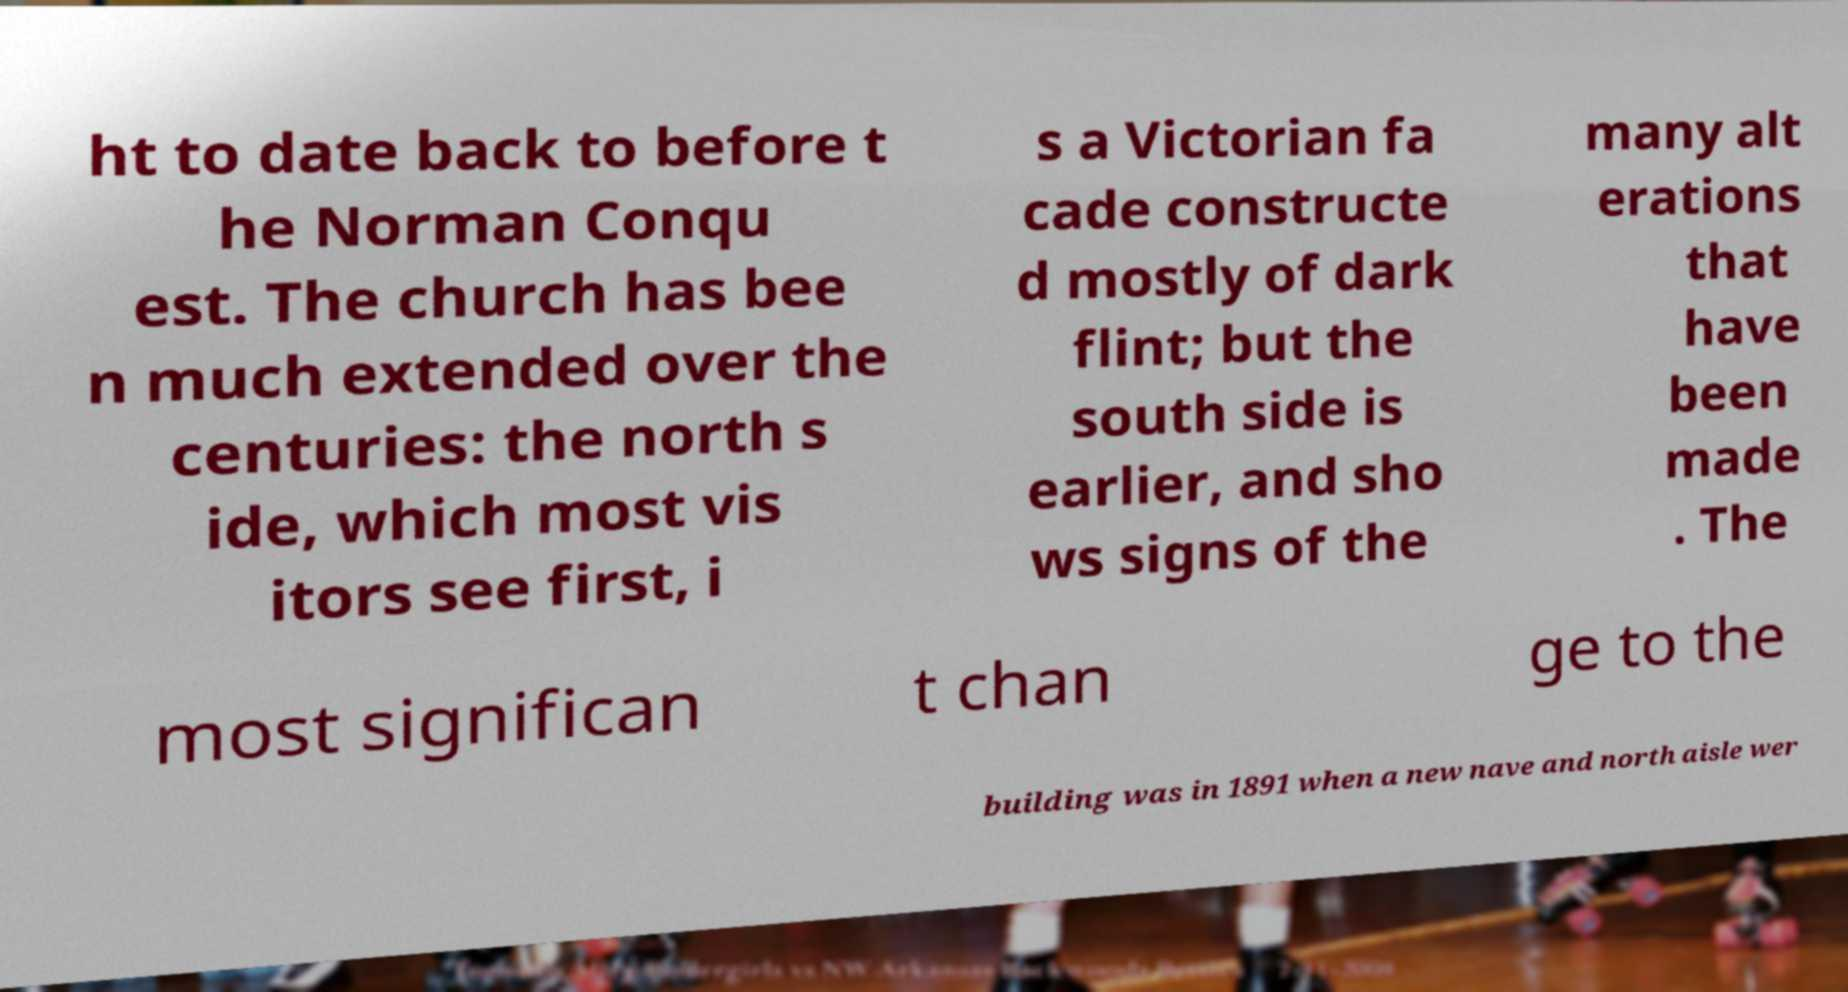I need the written content from this picture converted into text. Can you do that? ht to date back to before t he Norman Conqu est. The church has bee n much extended over the centuries: the north s ide, which most vis itors see first, i s a Victorian fa cade constructe d mostly of dark flint; but the south side is earlier, and sho ws signs of the many alt erations that have been made . The most significan t chan ge to the building was in 1891 when a new nave and north aisle wer 